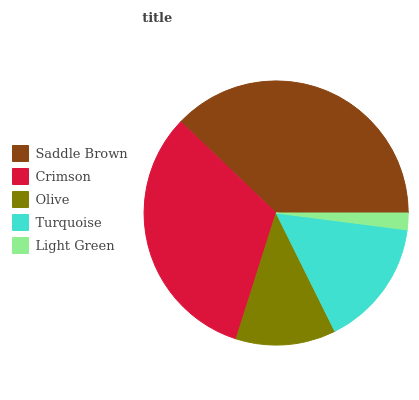Is Light Green the minimum?
Answer yes or no. Yes. Is Saddle Brown the maximum?
Answer yes or no. Yes. Is Crimson the minimum?
Answer yes or no. No. Is Crimson the maximum?
Answer yes or no. No. Is Saddle Brown greater than Crimson?
Answer yes or no. Yes. Is Crimson less than Saddle Brown?
Answer yes or no. Yes. Is Crimson greater than Saddle Brown?
Answer yes or no. No. Is Saddle Brown less than Crimson?
Answer yes or no. No. Is Turquoise the high median?
Answer yes or no. Yes. Is Turquoise the low median?
Answer yes or no. Yes. Is Crimson the high median?
Answer yes or no. No. Is Olive the low median?
Answer yes or no. No. 